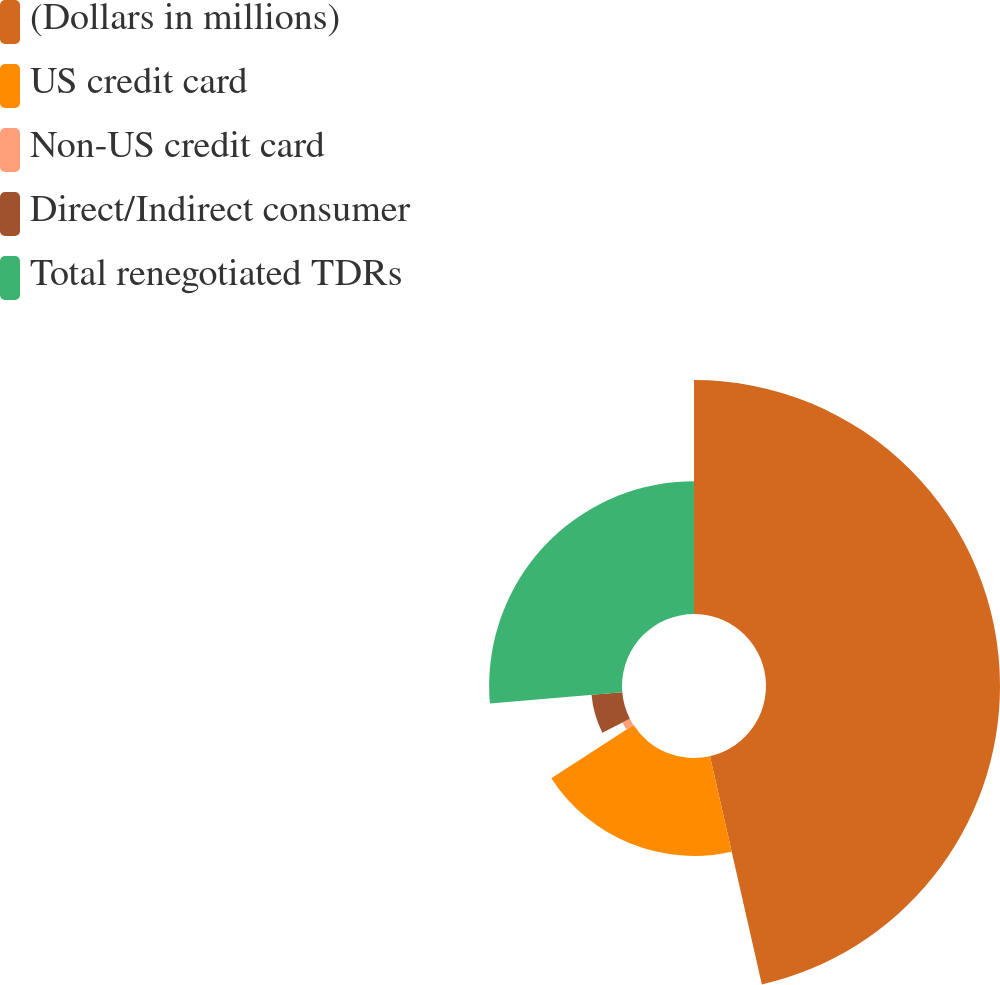<chart> <loc_0><loc_0><loc_500><loc_500><pie_chart><fcel>(Dollars in millions)<fcel>US credit card<fcel>Non-US credit card<fcel>Direct/Indirect consumer<fcel>Total renegotiated TDRs<nl><fcel>46.44%<fcel>19.43%<fcel>1.64%<fcel>6.12%<fcel>26.37%<nl></chart> 